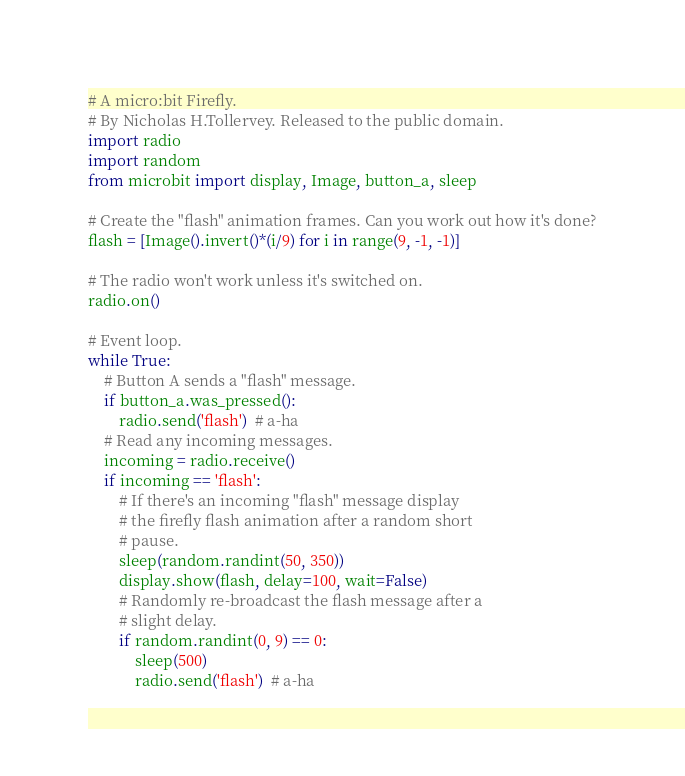<code> <loc_0><loc_0><loc_500><loc_500><_Python_># A micro:bit Firefly.
# By Nicholas H.Tollervey. Released to the public domain.
import radio
import random
from microbit import display, Image, button_a, sleep

# Create the "flash" animation frames. Can you work out how it's done?
flash = [Image().invert()*(i/9) for i in range(9, -1, -1)]

# The radio won't work unless it's switched on.
radio.on()

# Event loop.
while True:
    # Button A sends a "flash" message.
    if button_a.was_pressed():
        radio.send('flash')  # a-ha
    # Read any incoming messages.
    incoming = radio.receive()
    if incoming == 'flash':
        # If there's an incoming "flash" message display
        # the firefly flash animation after a random short
        # pause.
        sleep(random.randint(50, 350))
        display.show(flash, delay=100, wait=False)
        # Randomly re-broadcast the flash message after a
        # slight delay.
        if random.randint(0, 9) == 0:
            sleep(500)
            radio.send('flash')  # a-ha
</code> 